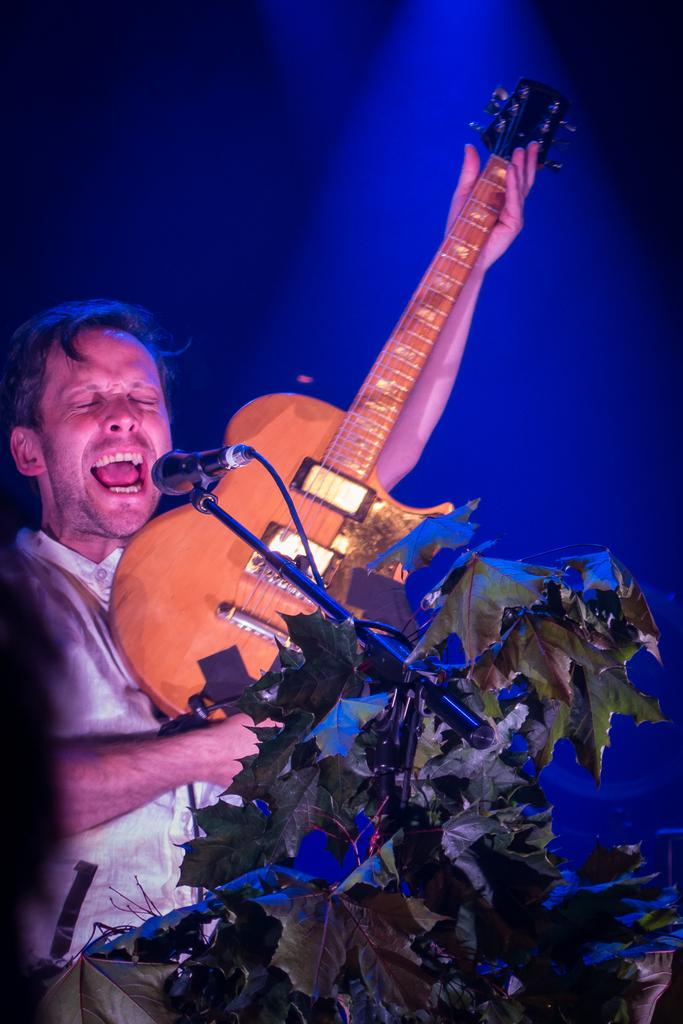What is the person in the image doing? The person is holding a guitar and standing in front of a microphone. What object is the person holding in the image? The person is holding a guitar. What can be seen in the background of the image? The background of the image is blue. Are there any plants visible in the image? Yes, there is a plant in the image. What type of hole can be seen in the image? There is no hole present in the image. What sound is being produced by the person in the image? The image does not provide any information about the sound being produced by the person; it only shows them holding a guitar and standing in front of a microphone. 